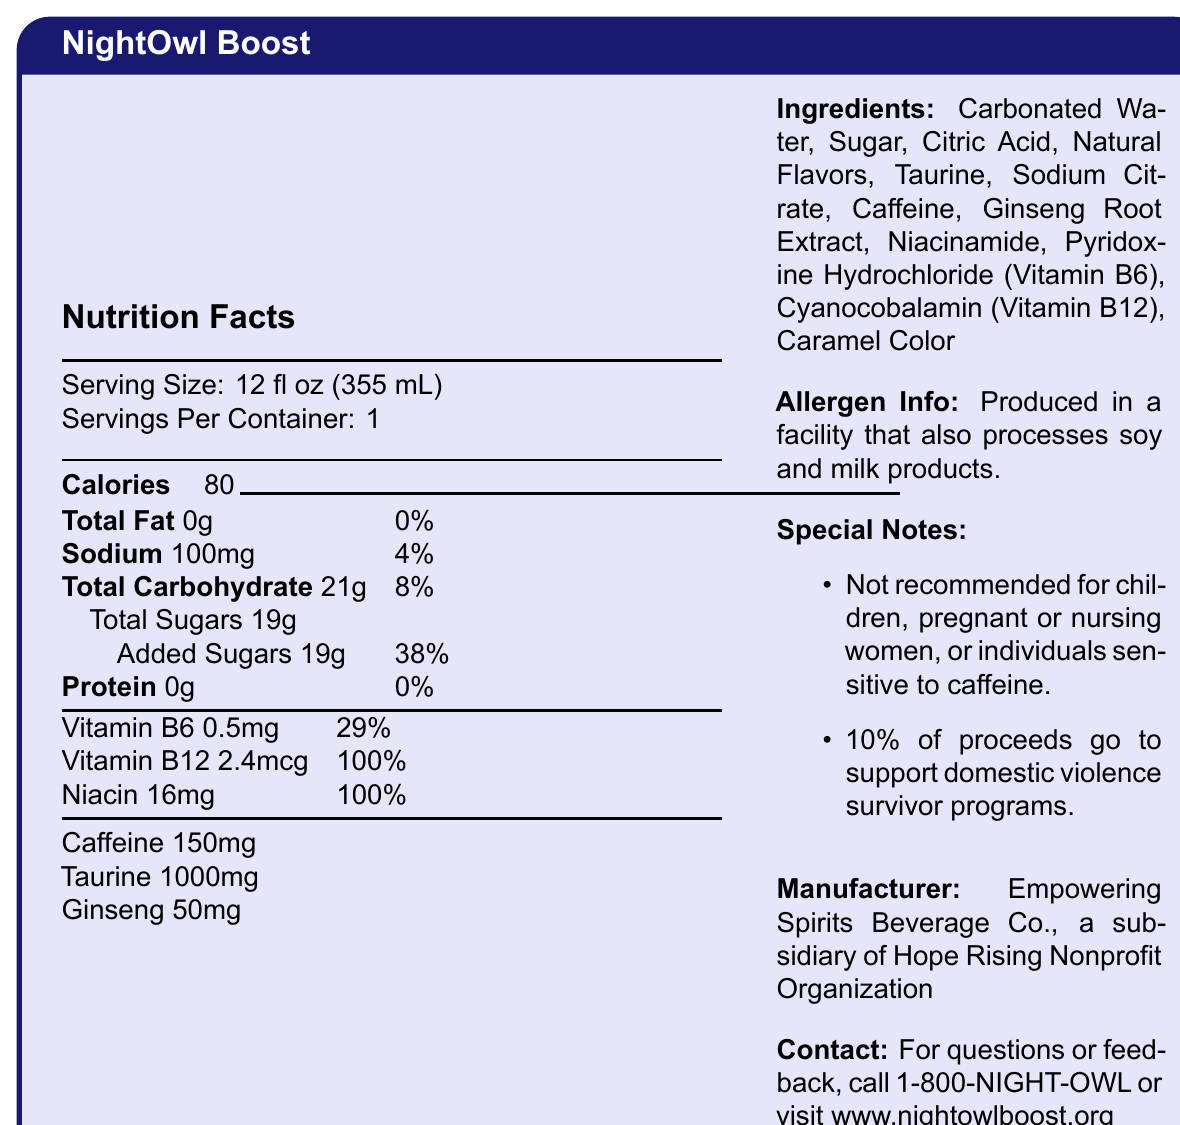what is the serving size for NightOwl Boost? The serving size is explicitly stated as 12 fl oz (355 mL) in the document.
Answer: 12 fl oz (355 mL) How many calories are there per serving? The document lists 80 calories per serving.
Answer: 80 How much sodium does NightOwl Boost contain? The document states that there are 100mg of sodium, which is 4% of the daily value.
Answer: 100mg What percentage of the daily value of Vitamin B12 does one serving of NightOwl Boost provide? The document shows that one serving contains 2.4mcg of Vitamin B12, which is 100% of the daily value.
Answer: 100% What is the total amount of sugars in NightOwl Boost? The document notes that the total sugars in one serving are 19g.
Answer: 19g which of the following ingredients is not listed in NightOwl Boost? 
A. Caffeine 
B. Ginseng 
C. Guarana 
D. Taurine The ingredients list in the document includes Caffeine, Ginseng, and Taurine, but not Guarana.
Answer: C. Guarana How much caffeine is in one serving of NightOwl Boost? 
I. 50mg 
II. 100mg 
III. 150mg 
IV. 200mg The document specifies that NightOwl Boost contains 150mg of caffeine per serving.
Answer: III. 150mg What is the daily value percentage of added sugars in NightOwl Boost? The document indicates that the added sugars amount to 38% of the daily value.
Answer: 38% Is NightOwl Boost recommended for pregnant or nursing women? The special notes section explicitly advises that the product is not recommended for children, pregnant or nursing women, or individuals sensitive to caffeine.
Answer: No Summarize the key nutritional and ingredient information about NightOwl Boost. This explanation includes the primary nutritional values and ingredient details, emphasizing the key points of the document.
Answer: NightOwl Boost is an energy drink with a serving size of 12 fl oz (355 mL) and contains 80 calories per serving. Key nutrients per serving include 0g total fat, 100mg sodium (4% DV), 21g total carbohydrates (8% DV), 19g total sugars (including 19g added sugars, 38% DV). It provides 0.5mg Vitamin B6 (29% DV), 2.4mcg Vitamin B12 (100% DV), and 16mg Niacin (100% DV). It contains 150mg caffeine, 1000mg taurine, and 50mg ginseng. The main ingredients are carbonated water, sugar, citric acid, and natural flavors. It is produced in a facility that processes soy and milk products and 10% of proceeds support domestic violence survivor programs. Who is the manufacturer of NightOwl Boost? This information is stated in the section labeled "Manufacturer."
Answer: Empowering Spirits Beverage Co., a subsidiary of Hope Rising Nonprofit Organization Can you determine how many grams of carbohydrates are from sugars? The document shows that the total carbohydrates amount to 21g, with 19g specifically listed as total sugars.
Answer: 19g What are the main functions of taurine and ginseng in an energy drink? The document lists taurine and ginseng as ingredients but doesn't provide their specific functions.
Answer: Cannot be determined What is the toll-free number to contact for questions or feedback about NightOwl Boost? This contact information is provided under the special notes section.
Answer: 1-800-NIGHT-OWL 